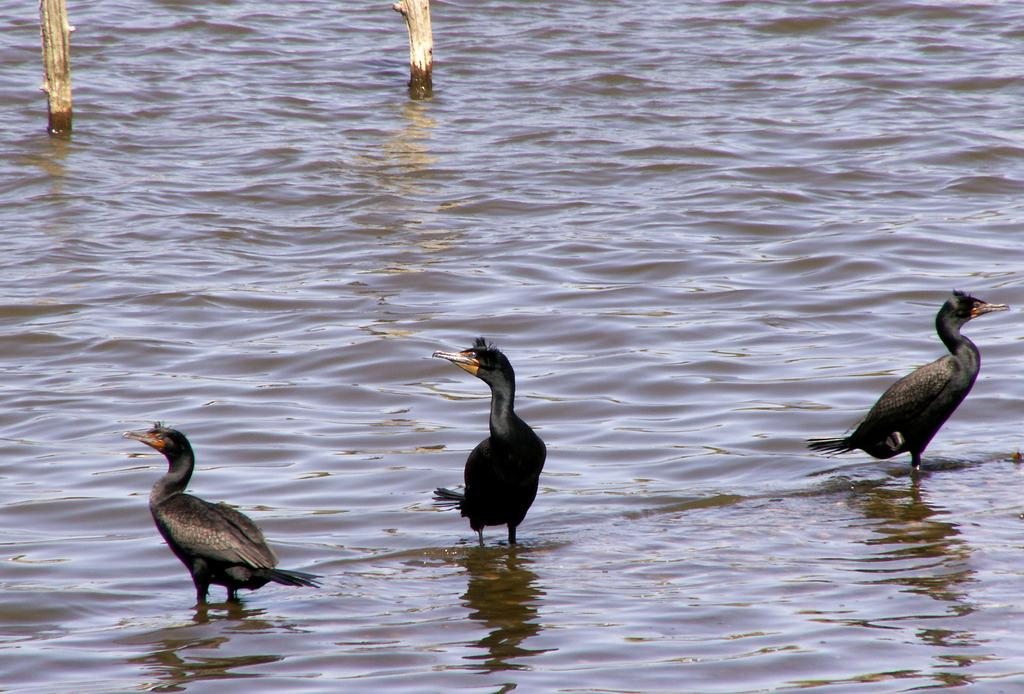What type of animals can be seen in the image? Birds can be seen in the image. What is the primary element in which the birds are situated? The birds are situated in water. What type of structures are present in the image? There are wooden poles in the image. What type of chess piece is floating on the water in the image? There is no chess piece present in the image; it features birds in the water and wooden poles. 